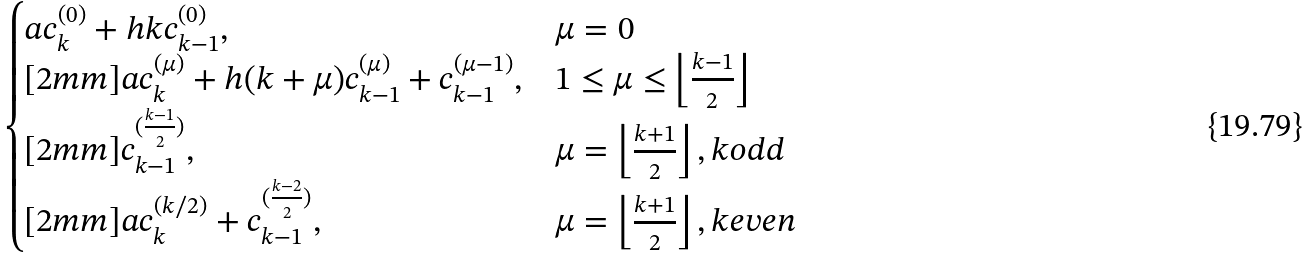Convert formula to latex. <formula><loc_0><loc_0><loc_500><loc_500>\begin{cases} a c _ { k } ^ { ( 0 ) } + h k c _ { k - 1 } ^ { ( 0 ) } , & \mu = 0 \\ [ 2 m m ] a c _ { k } ^ { ( \mu ) } + h ( k + \mu ) c _ { k - 1 } ^ { ( \mu ) } + c _ { k - 1 } ^ { ( \mu - 1 ) } , & 1 \leq \mu \leq \left \lfloor \frac { k - 1 } { 2 } \right \rfloor \\ [ 2 m m ] c _ { k - 1 } ^ { ( \frac { k - 1 } { 2 } ) } , & \mu = \left \lfloor \frac { k + 1 } { 2 } \right \rfloor , k o d d \\ [ 2 m m ] a c _ { k } ^ { ( k / 2 ) } + c _ { k - 1 } ^ { ( \frac { k - 2 } { 2 } ) } , & \mu = \left \lfloor \frac { k + 1 } { 2 } \right \rfloor , k e v e n \end{cases}</formula> 